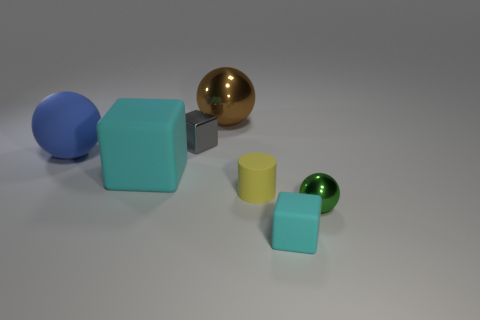What shape is the thing that is in front of the rubber sphere and on the left side of the brown metal object?
Ensure brevity in your answer.  Cube. What is the color of the other shiny object that is the same shape as the green object?
Your answer should be compact. Brown. Is there anything else that is the same color as the large shiny thing?
Provide a short and direct response. No. What is the shape of the cyan thing behind the metallic ball in front of the small shiny thing that is behind the big cyan block?
Your answer should be compact. Cube. Is the size of the cyan block that is in front of the green ball the same as the rubber cube that is behind the green ball?
Provide a short and direct response. No. What number of big cyan things are made of the same material as the small yellow thing?
Offer a very short reply. 1. There is a cyan cube behind the ball to the right of the small matte block; what number of cyan things are right of it?
Offer a terse response. 1. Is the shape of the large blue object the same as the large brown thing?
Keep it short and to the point. Yes. Is there a small cyan thing that has the same shape as the blue object?
Ensure brevity in your answer.  No. What is the shape of the blue object that is the same size as the brown sphere?
Provide a short and direct response. Sphere. 